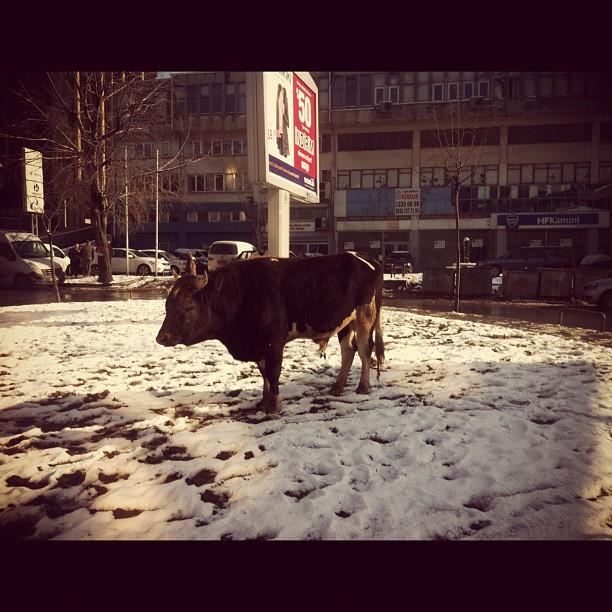Is the cow eating?
Short answer required. No. Has it been snowing?
Answer briefly. Yes. Why can't the cow eat grass here?
Concise answer only. Snow. 